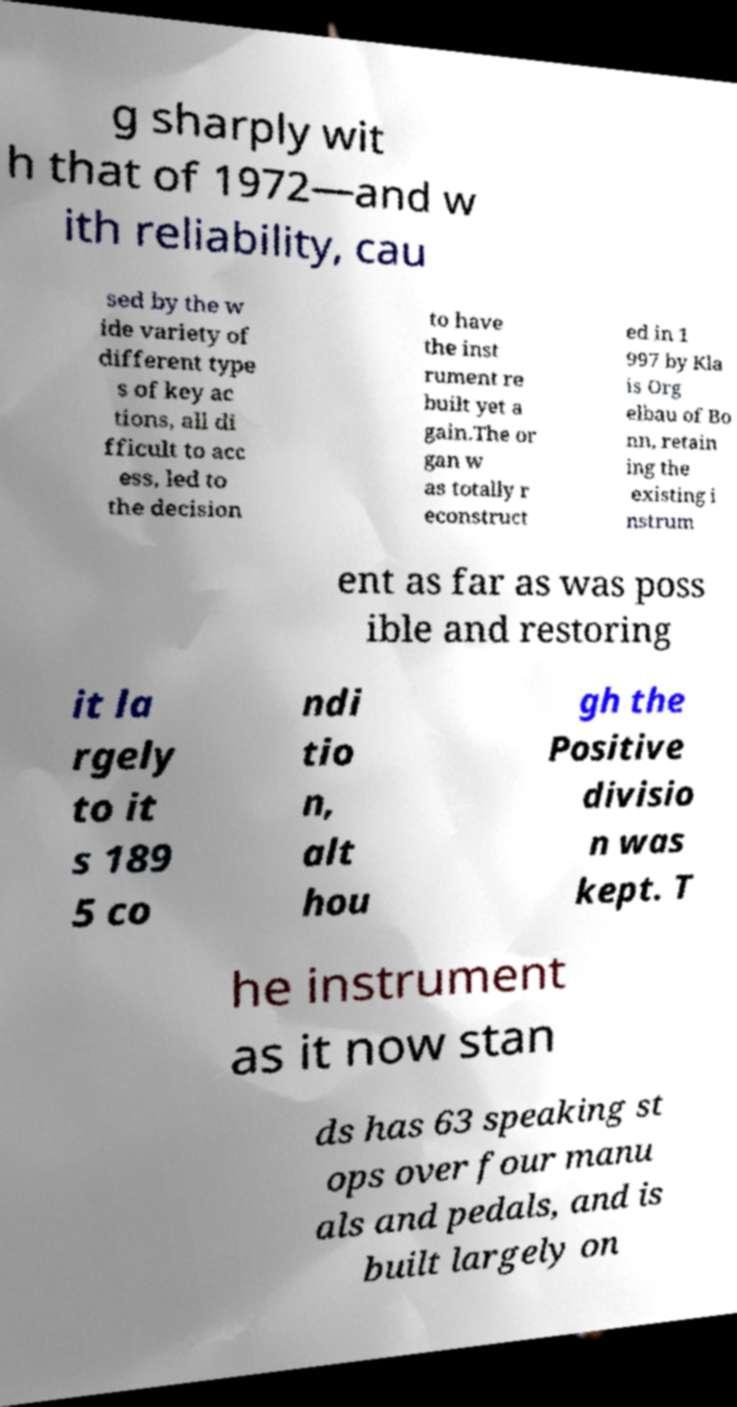Please read and relay the text visible in this image. What does it say? g sharply wit h that of 1972—and w ith reliability, cau sed by the w ide variety of different type s of key ac tions, all di fficult to acc ess, led to the decision to have the inst rument re built yet a gain.The or gan w as totally r econstruct ed in 1 997 by Kla is Org elbau of Bo nn, retain ing the existing i nstrum ent as far as was poss ible and restoring it la rgely to it s 189 5 co ndi tio n, alt hou gh the Positive divisio n was kept. T he instrument as it now stan ds has 63 speaking st ops over four manu als and pedals, and is built largely on 